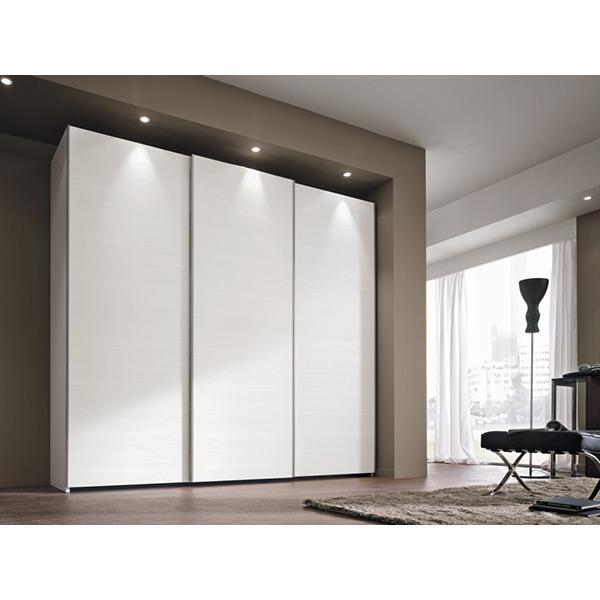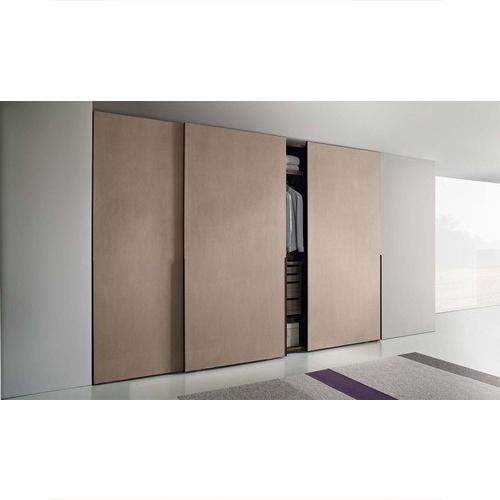The first image is the image on the left, the second image is the image on the right. Evaluate the accuracy of this statement regarding the images: "there is a closet with a curtained window on the wall to the right". Is it true? Answer yes or no. Yes. 